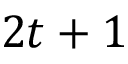<formula> <loc_0><loc_0><loc_500><loc_500>2 t + 1</formula> 